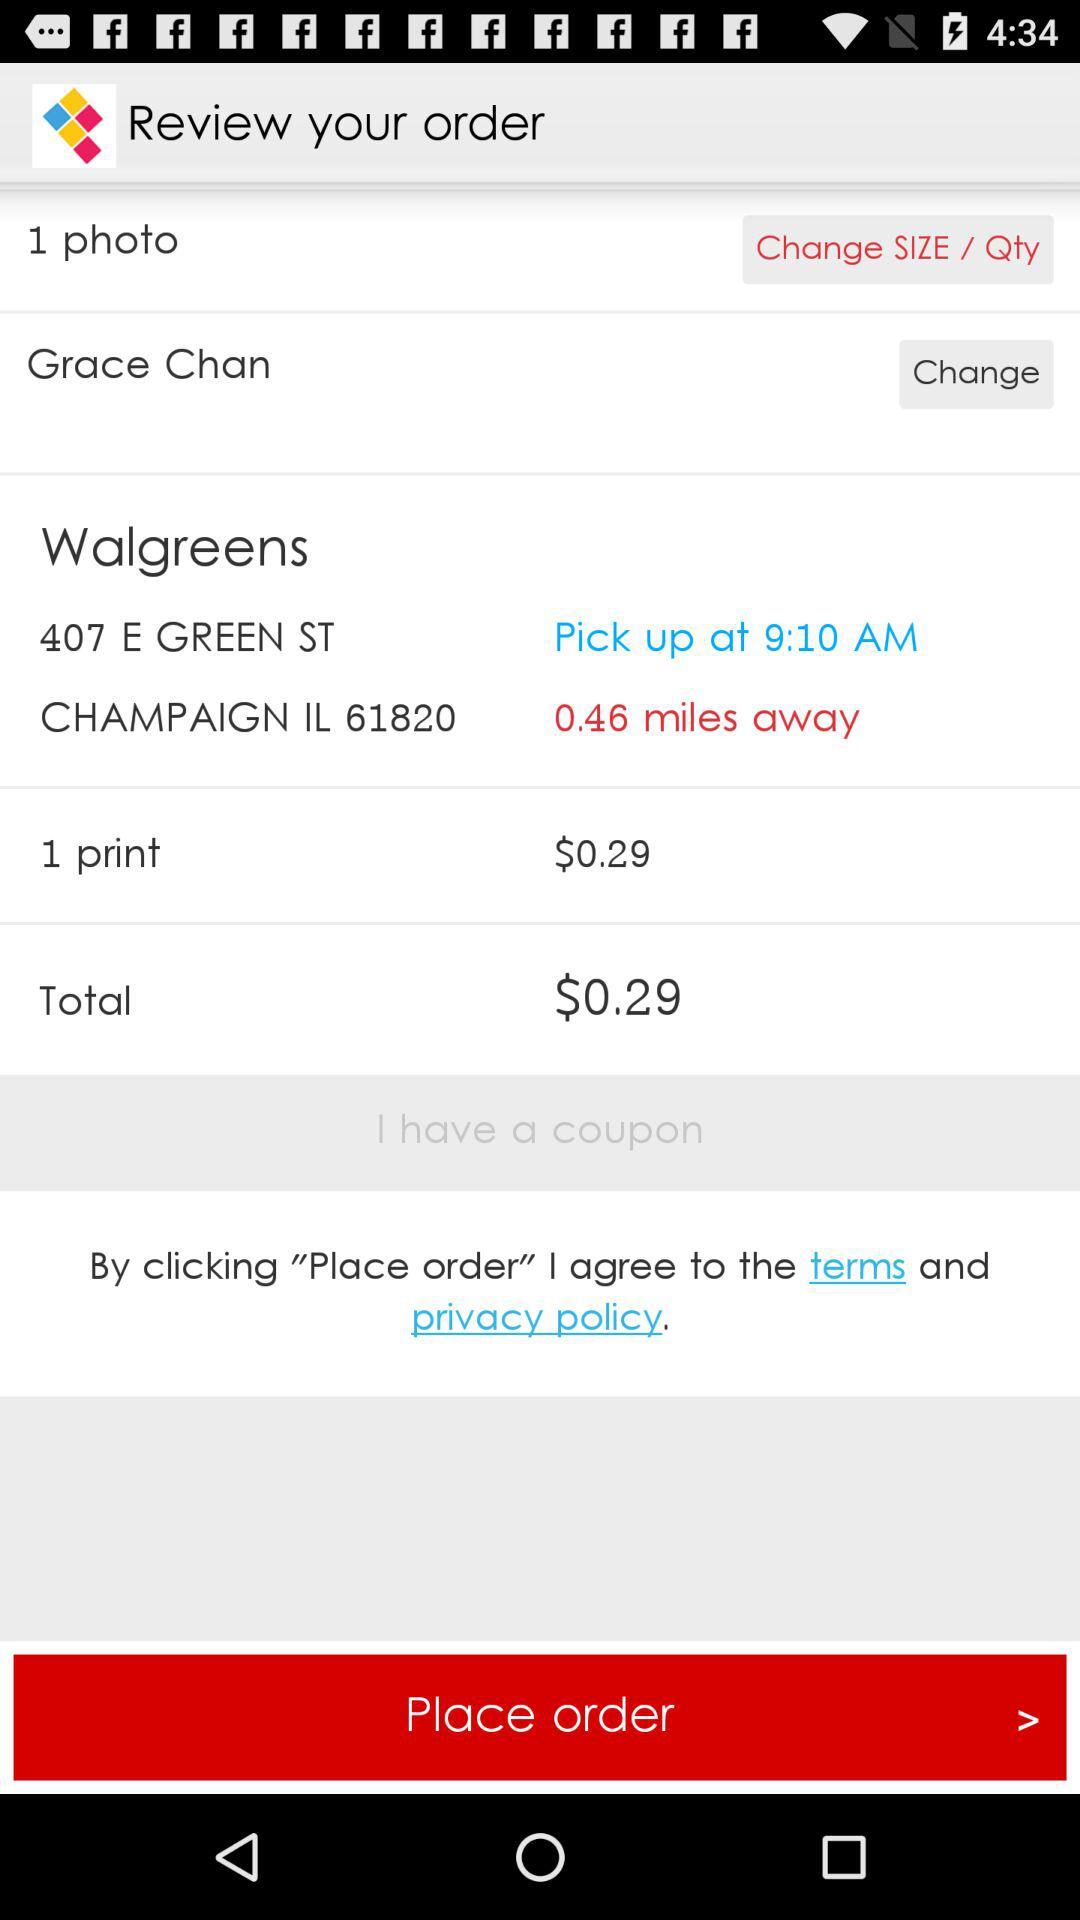What is the user name? The user name is "'Grace Chan". 